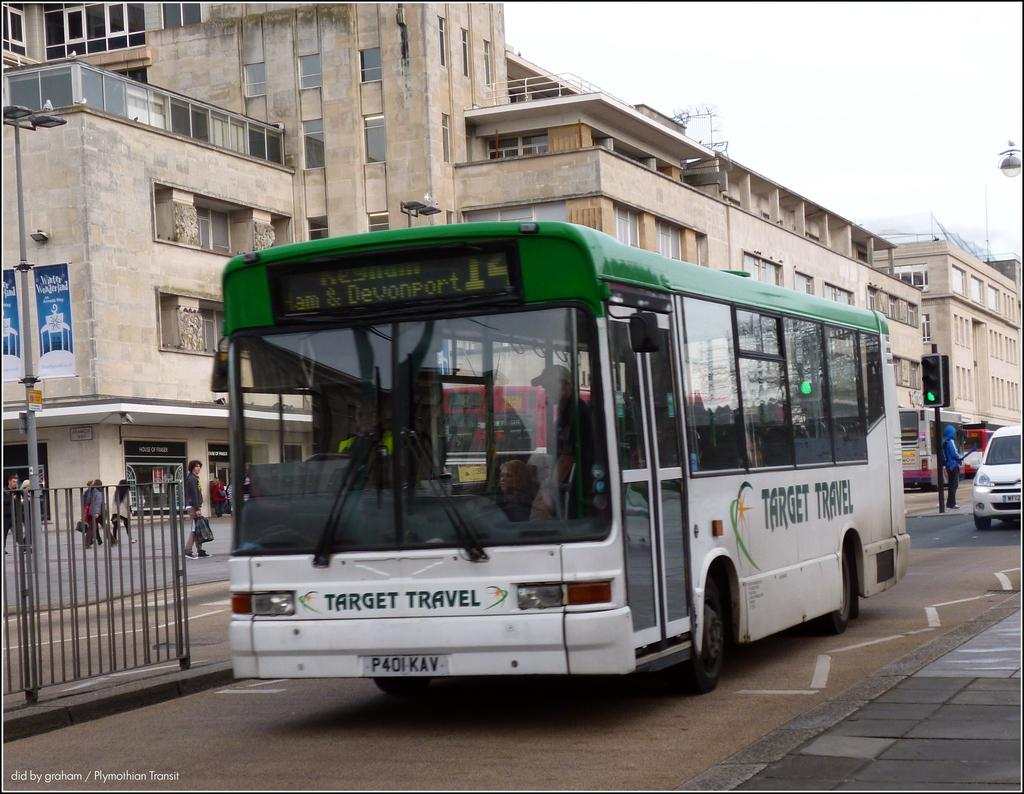<image>
Present a compact description of the photo's key features. An outside scene where Target Travel bus is parked. 